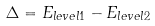<formula> <loc_0><loc_0><loc_500><loc_500>\Delta = E _ { l e v e l 1 } - E _ { l e v e l 2 }</formula> 